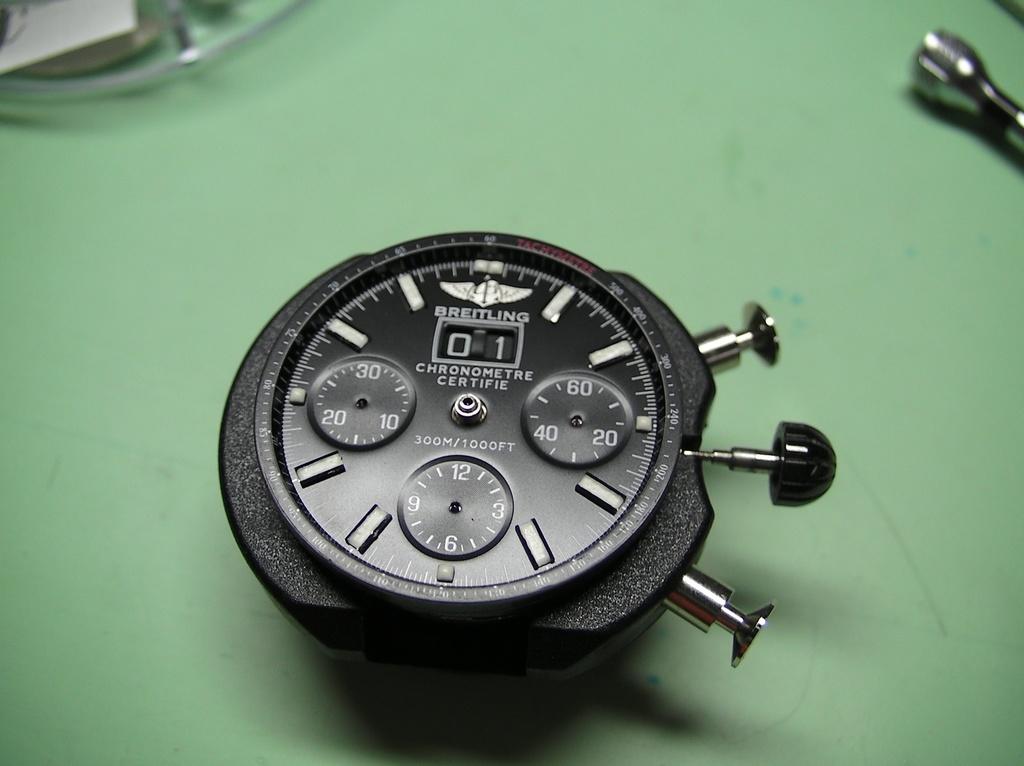What brand of watch is this?
Give a very brief answer. Breitling. What are the three numbers on the circle on the right?
Ensure brevity in your answer.  20 40 60. 